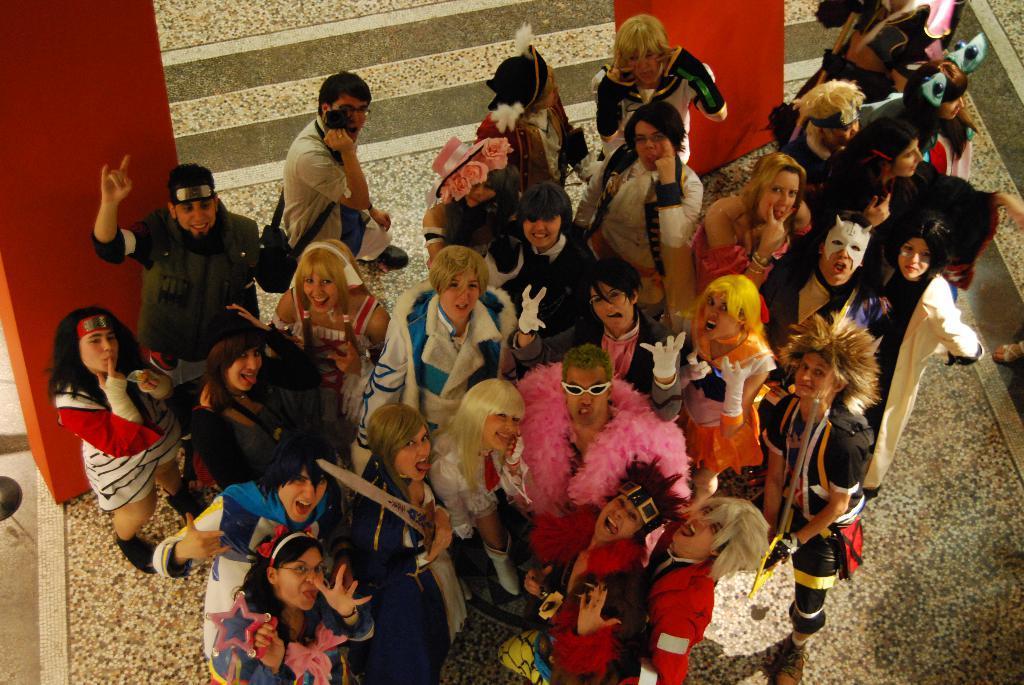Describe this image in one or two sentences. In this image at the bottom there are few people who are standing and some of them are wearing some costumes like glasses and hats, in the background there are two boards. At the bottom there is a floor. 